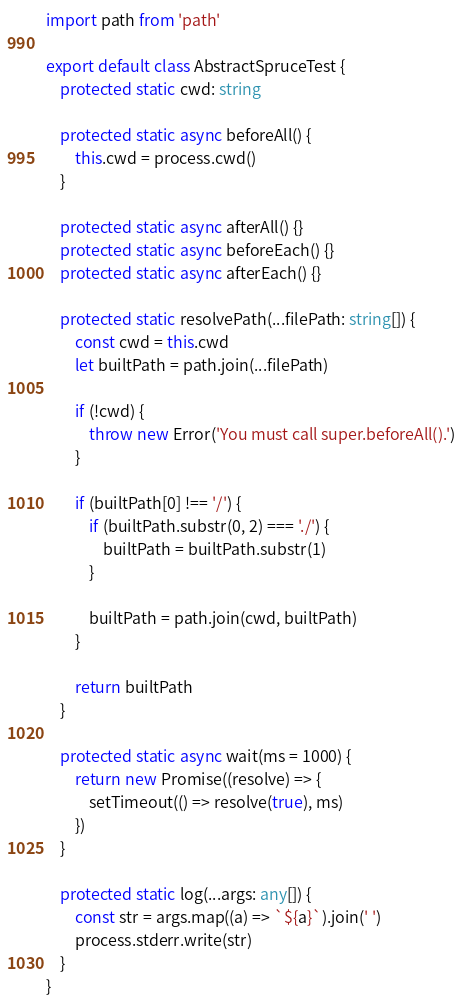Convert code to text. <code><loc_0><loc_0><loc_500><loc_500><_TypeScript_>import path from 'path'

export default class AbstractSpruceTest {
	protected static cwd: string

	protected static async beforeAll() {
		this.cwd = process.cwd()
	}

	protected static async afterAll() {}
	protected static async beforeEach() {}
	protected static async afterEach() {}

	protected static resolvePath(...filePath: string[]) {
		const cwd = this.cwd
		let builtPath = path.join(...filePath)

		if (!cwd) {
			throw new Error('You must call super.beforeAll().')
		}

		if (builtPath[0] !== '/') {
			if (builtPath.substr(0, 2) === './') {
				builtPath = builtPath.substr(1)
			}

			builtPath = path.join(cwd, builtPath)
		}

		return builtPath
	}

	protected static async wait(ms = 1000) {
		return new Promise((resolve) => {
			setTimeout(() => resolve(true), ms)
		})
	}

	protected static log(...args: any[]) {
		const str = args.map((a) => `${a}`).join(' ')
		process.stderr.write(str)
	}
}
</code> 